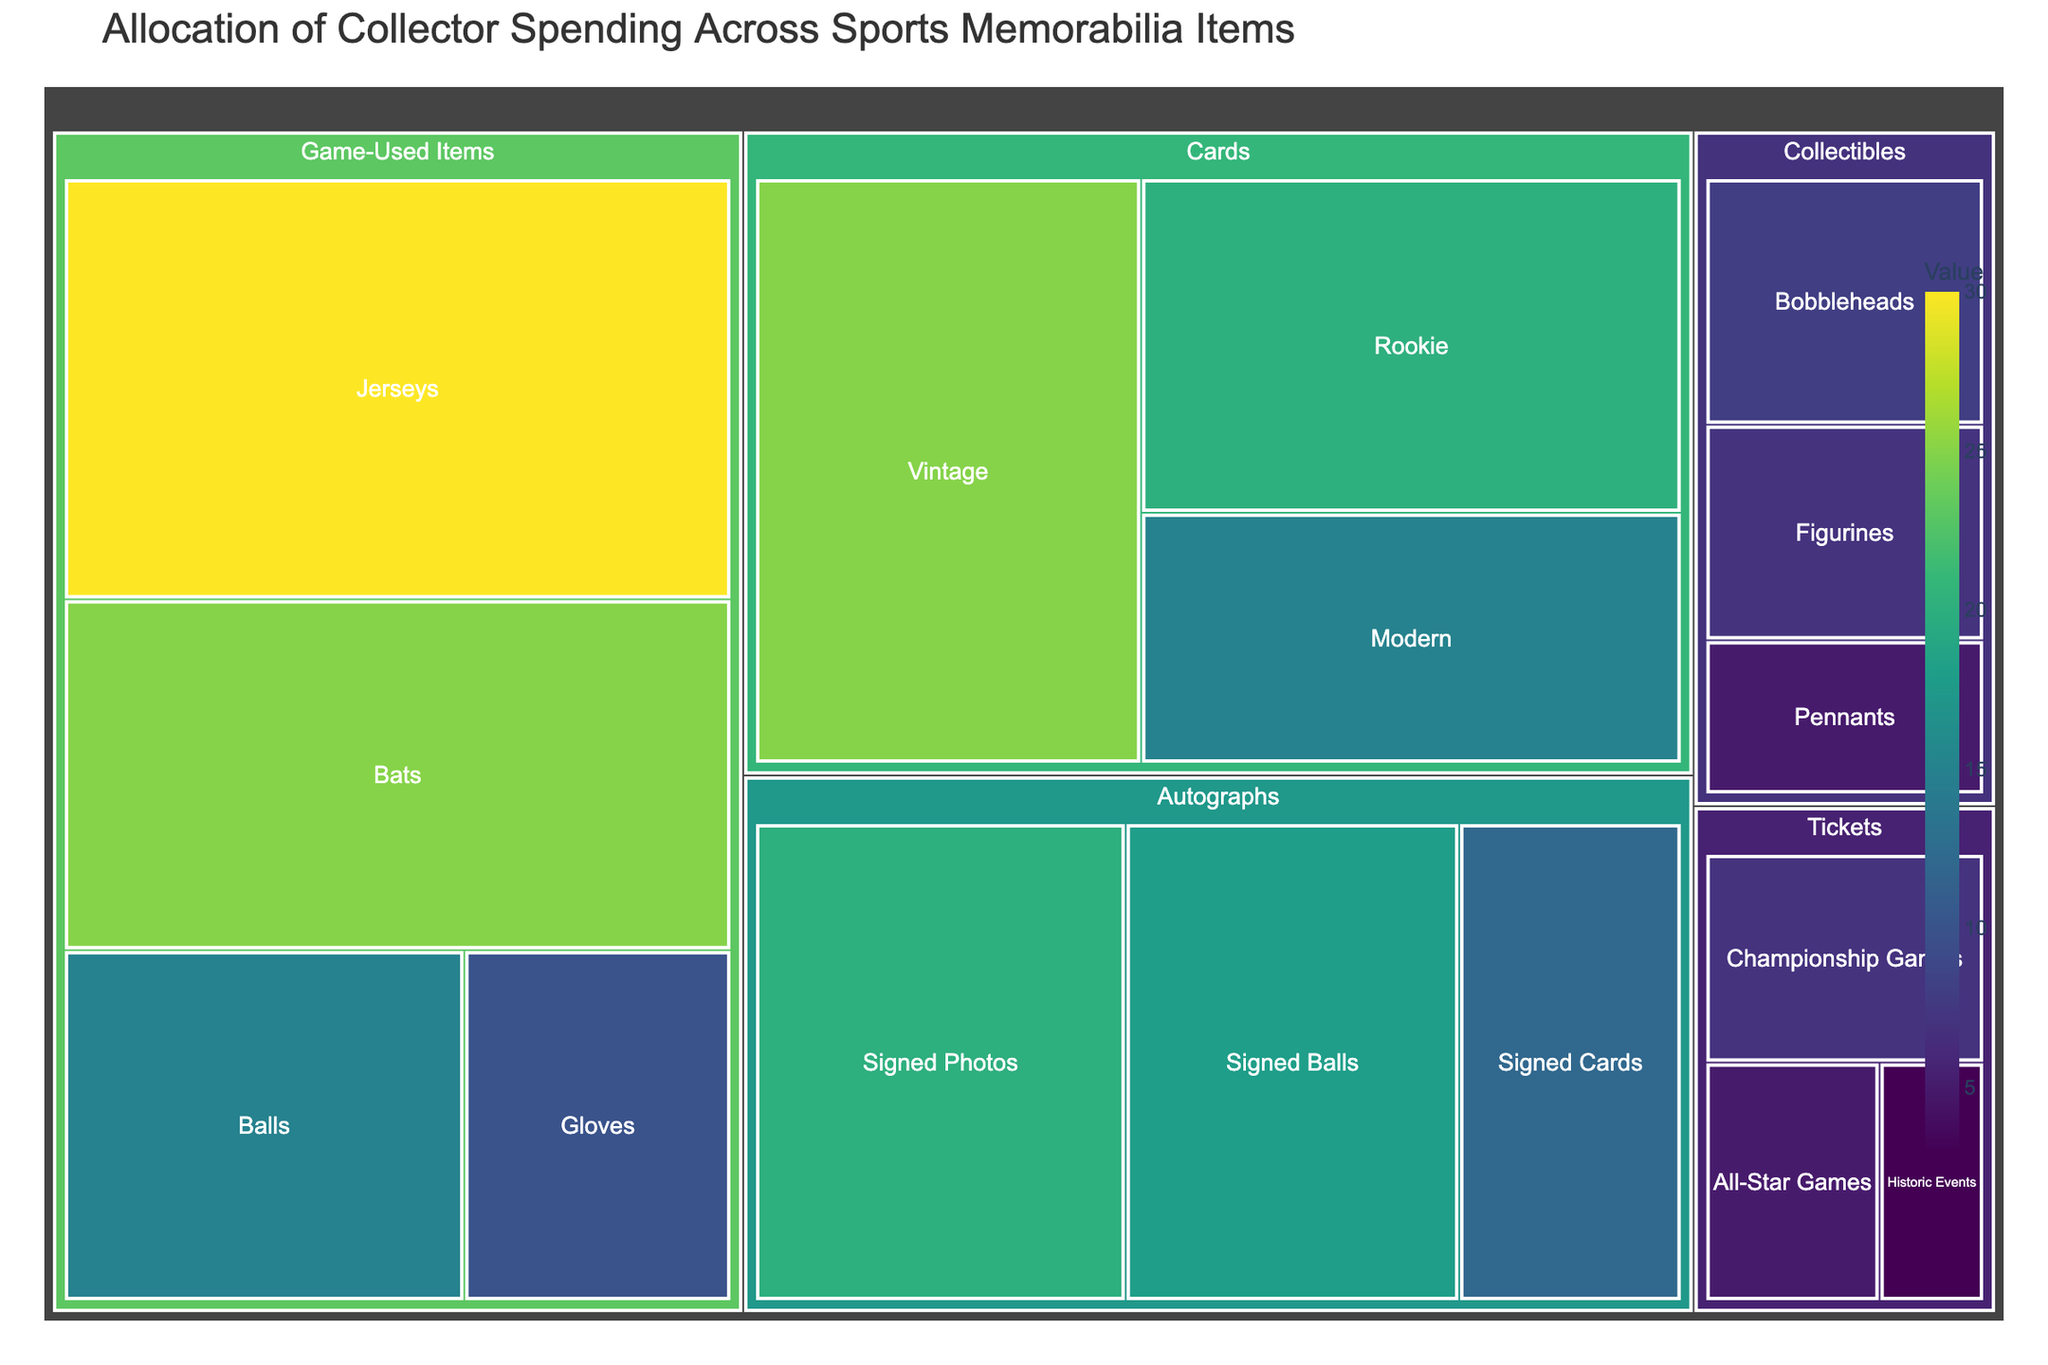What's the title of the figure? The title of the figure is located at the top and is clearly stated.
Answer: Allocation of Collector Spending Across Sports Memorabilia Items How many subcategories are under the 'Game-Used Items' category? By visually inspecting the treemap, one can count the number of subcategories under the 'Game-Used Items' category.
Answer: 4 What is the value allocated to 'Signed Balls' in the 'Autographs' category? The value is displayed on the treemap for the 'Signed Balls' subcategory in the 'Autographs' category.
Answer: 18 Which category has the highest total value? By examining the size of the blocks in the treemap, the 'Game-Used Items' category occupies the largest area, indicating the highest total value.
Answer: Game-Used Items How much more is spent on 'Rookie' cards compared to 'Modern' cards? The values for 'Rookie' and 'Modern' cards can be directly read from the treemap, and the difference can be calculated. 'Rookie' cards = 20, 'Modern' cards = 15. The difference is 20 - 15 = 5.
Answer: 5 What is the total value for all subcategories under 'Collectibles'? Each subcategory value under 'Collectibles' is summed up: Bobbleheads (8) + Figurines (7) + Pennants (5). The total is 8 + 7 + 5 = 20.
Answer: 20 Which subcategory under 'Tickets' has the lowest value? The smallest block size under 'Tickets' indicates the subcategory with the lowest value, which is 'Historic Events'.
Answer: Historic Events What is the average value of the 'Cards' subcategories? The values for each subcategory under 'Cards' are summed and then divided by the number of subcategories. 'Vintage' (25) + 'Rookie' (20) + 'Modern' (15) = 60. There are 3 subcategories. The average is 60 / 3 = 20.
Answer: 20 What is the combined value of all 'Autographs' subcategories? Sum the values of all 'Autographs' subcategories: Signed Photos (20) + Signed Balls (18) + Signed Cards (12). The total is 20 + 18 + 12 = 50.
Answer: 50 Which category has the second highest total value? After identifying the category with the highest value (Game-Used Items), the next largest block must be identified. 'Autographs' has a significant block size after 'Game-Used Items'.
Answer: Autographs 